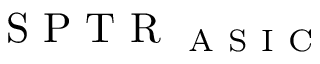Convert formula to latex. <formula><loc_0><loc_0><loc_500><loc_500>S P T R _ { A S I C }</formula> 